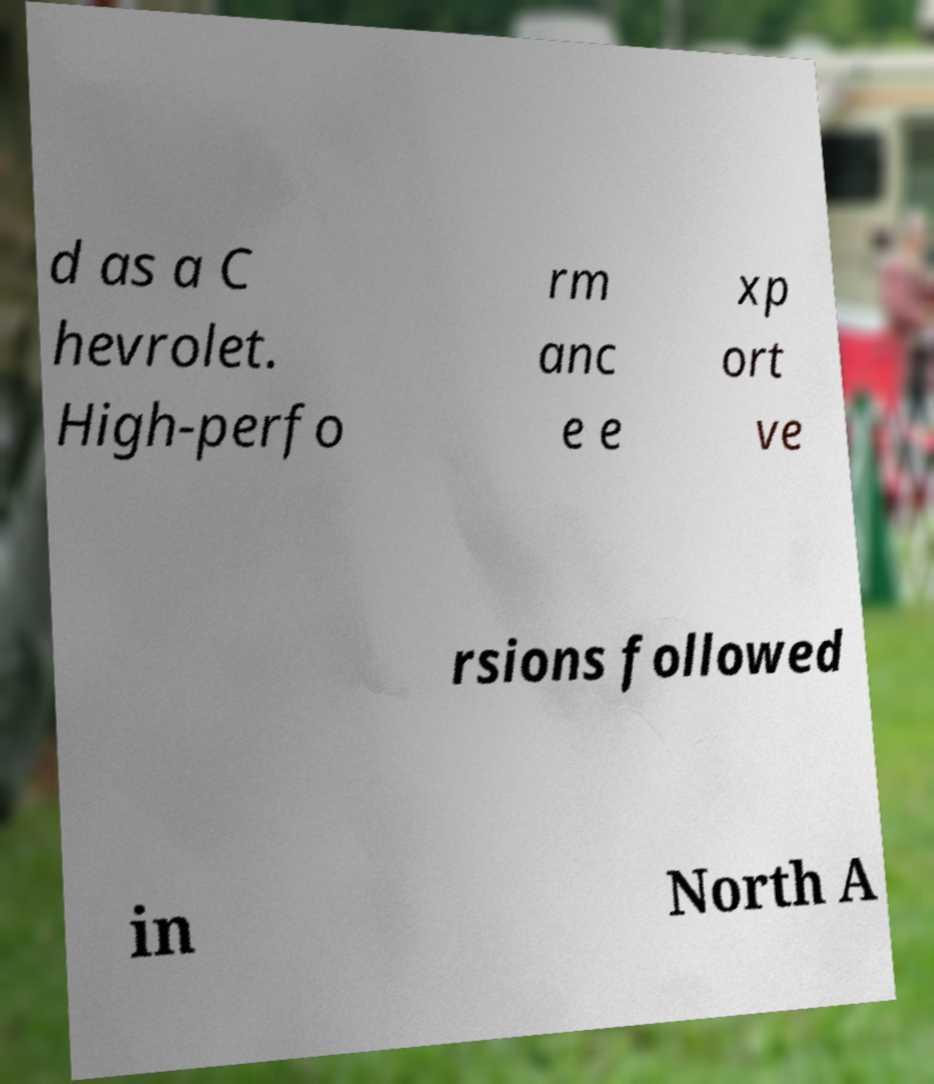Could you assist in decoding the text presented in this image and type it out clearly? d as a C hevrolet. High-perfo rm anc e e xp ort ve rsions followed in North A 